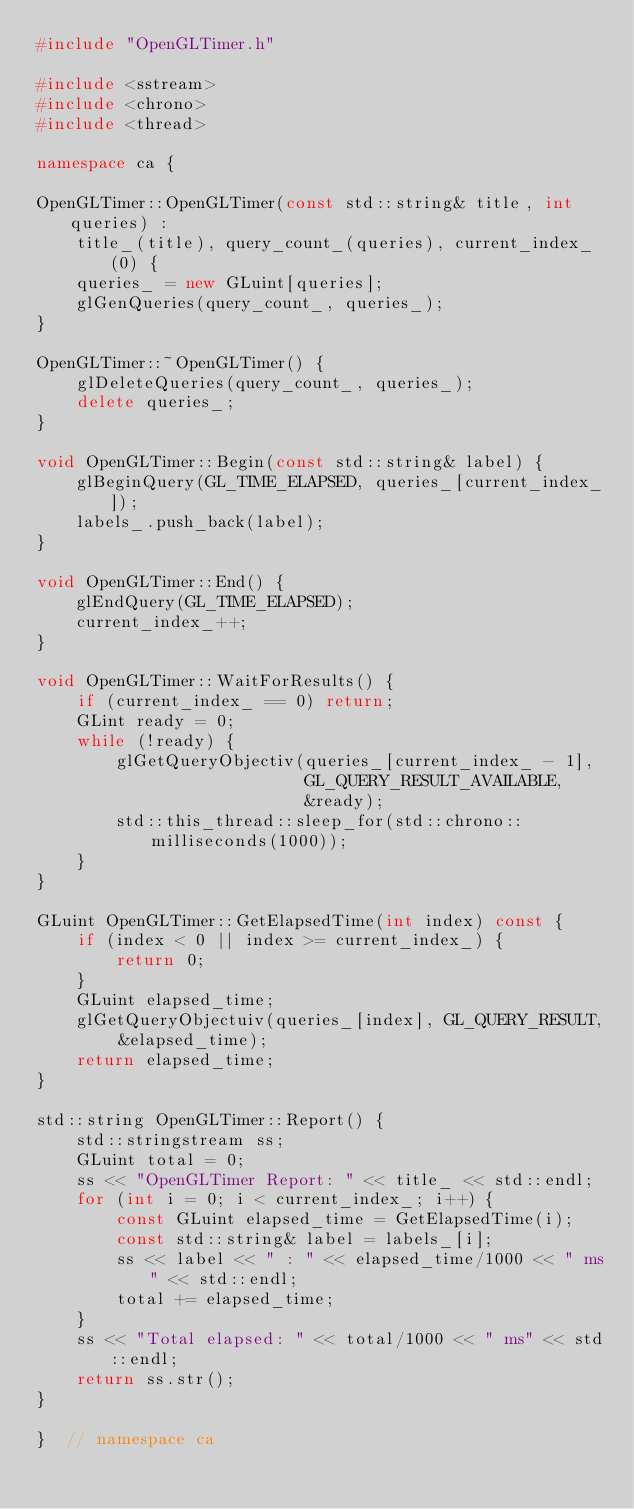Convert code to text. <code><loc_0><loc_0><loc_500><loc_500><_C++_>#include "OpenGLTimer.h"

#include <sstream>
#include <chrono>
#include <thread>

namespace ca {

OpenGLTimer::OpenGLTimer(const std::string& title, int queries) :
    title_(title), query_count_(queries), current_index_(0) {
    queries_ = new GLuint[queries];
    glGenQueries(query_count_, queries_);
}

OpenGLTimer::~OpenGLTimer() {
    glDeleteQueries(query_count_, queries_);
    delete queries_;
}

void OpenGLTimer::Begin(const std::string& label) {
    glBeginQuery(GL_TIME_ELAPSED, queries_[current_index_]);
    labels_.push_back(label);
}

void OpenGLTimer::End() {
    glEndQuery(GL_TIME_ELAPSED);
    current_index_++;
}

void OpenGLTimer::WaitForResults() {
    if (current_index_ == 0) return;
    GLint ready = 0;
    while (!ready) {
        glGetQueryObjectiv(queries_[current_index_ - 1],
                           GL_QUERY_RESULT_AVAILABLE,
                           &ready);
        std::this_thread::sleep_for(std::chrono::milliseconds(1000));
    }
}

GLuint OpenGLTimer::GetElapsedTime(int index) const {
    if (index < 0 || index >= current_index_) {
        return 0;
    }
    GLuint elapsed_time;
    glGetQueryObjectuiv(queries_[index], GL_QUERY_RESULT, &elapsed_time);
    return elapsed_time;
}

std::string OpenGLTimer::Report() {
    std::stringstream ss;
    GLuint total = 0;
    ss << "OpenGLTimer Report: " << title_ << std::endl;
    for (int i = 0; i < current_index_; i++) {
        const GLuint elapsed_time = GetElapsedTime(i);
        const std::string& label = labels_[i];
        ss << label << " : " << elapsed_time/1000 << " ms" << std::endl;
        total += elapsed_time;
    }
    ss << "Total elapsed: " << total/1000 << " ms" << std::endl;
    return ss.str();
}

}  // namespace ca</code> 